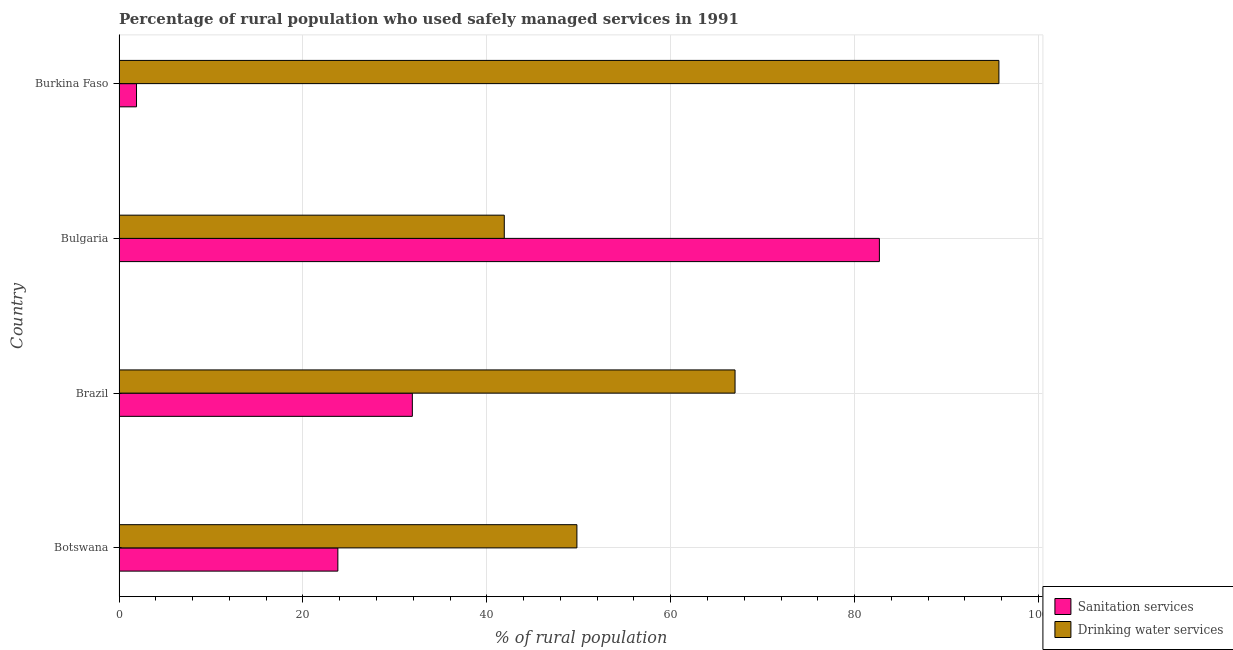How many groups of bars are there?
Provide a succinct answer. 4. Are the number of bars per tick equal to the number of legend labels?
Your response must be concise. Yes. In how many cases, is the number of bars for a given country not equal to the number of legend labels?
Give a very brief answer. 0. What is the percentage of rural population who used drinking water services in Botswana?
Keep it short and to the point. 49.8. Across all countries, what is the maximum percentage of rural population who used sanitation services?
Provide a succinct answer. 82.7. Across all countries, what is the minimum percentage of rural population who used drinking water services?
Give a very brief answer. 41.9. In which country was the percentage of rural population who used sanitation services minimum?
Offer a terse response. Burkina Faso. What is the total percentage of rural population who used drinking water services in the graph?
Provide a succinct answer. 254.4. What is the difference between the percentage of rural population who used sanitation services in Botswana and that in Bulgaria?
Your answer should be compact. -58.9. What is the average percentage of rural population who used sanitation services per country?
Ensure brevity in your answer.  35.08. What is the difference between the percentage of rural population who used sanitation services and percentage of rural population who used drinking water services in Bulgaria?
Keep it short and to the point. 40.8. In how many countries, is the percentage of rural population who used sanitation services greater than 24 %?
Give a very brief answer. 2. What is the ratio of the percentage of rural population who used sanitation services in Botswana to that in Bulgaria?
Ensure brevity in your answer.  0.29. Is the difference between the percentage of rural population who used sanitation services in Botswana and Burkina Faso greater than the difference between the percentage of rural population who used drinking water services in Botswana and Burkina Faso?
Provide a succinct answer. Yes. What is the difference between the highest and the second highest percentage of rural population who used sanitation services?
Your response must be concise. 50.8. What is the difference between the highest and the lowest percentage of rural population who used sanitation services?
Your answer should be very brief. 80.8. In how many countries, is the percentage of rural population who used drinking water services greater than the average percentage of rural population who used drinking water services taken over all countries?
Offer a very short reply. 2. What does the 1st bar from the top in Burkina Faso represents?
Keep it short and to the point. Drinking water services. What does the 2nd bar from the bottom in Brazil represents?
Give a very brief answer. Drinking water services. How many bars are there?
Provide a short and direct response. 8. How many countries are there in the graph?
Make the answer very short. 4. What is the difference between two consecutive major ticks on the X-axis?
Offer a very short reply. 20. Does the graph contain any zero values?
Offer a very short reply. No. What is the title of the graph?
Provide a short and direct response. Percentage of rural population who used safely managed services in 1991. What is the label or title of the X-axis?
Your answer should be very brief. % of rural population. What is the label or title of the Y-axis?
Provide a short and direct response. Country. What is the % of rural population of Sanitation services in Botswana?
Give a very brief answer. 23.8. What is the % of rural population of Drinking water services in Botswana?
Ensure brevity in your answer.  49.8. What is the % of rural population of Sanitation services in Brazil?
Make the answer very short. 31.9. What is the % of rural population in Drinking water services in Brazil?
Ensure brevity in your answer.  67. What is the % of rural population in Sanitation services in Bulgaria?
Your response must be concise. 82.7. What is the % of rural population in Drinking water services in Bulgaria?
Give a very brief answer. 41.9. What is the % of rural population of Drinking water services in Burkina Faso?
Offer a very short reply. 95.7. Across all countries, what is the maximum % of rural population of Sanitation services?
Offer a very short reply. 82.7. Across all countries, what is the maximum % of rural population in Drinking water services?
Ensure brevity in your answer.  95.7. Across all countries, what is the minimum % of rural population in Drinking water services?
Offer a very short reply. 41.9. What is the total % of rural population of Sanitation services in the graph?
Ensure brevity in your answer.  140.3. What is the total % of rural population in Drinking water services in the graph?
Your answer should be compact. 254.4. What is the difference between the % of rural population of Drinking water services in Botswana and that in Brazil?
Provide a succinct answer. -17.2. What is the difference between the % of rural population of Sanitation services in Botswana and that in Bulgaria?
Your answer should be very brief. -58.9. What is the difference between the % of rural population in Drinking water services in Botswana and that in Bulgaria?
Provide a short and direct response. 7.9. What is the difference between the % of rural population in Sanitation services in Botswana and that in Burkina Faso?
Give a very brief answer. 21.9. What is the difference between the % of rural population of Drinking water services in Botswana and that in Burkina Faso?
Offer a terse response. -45.9. What is the difference between the % of rural population of Sanitation services in Brazil and that in Bulgaria?
Offer a terse response. -50.8. What is the difference between the % of rural population of Drinking water services in Brazil and that in Bulgaria?
Offer a terse response. 25.1. What is the difference between the % of rural population in Drinking water services in Brazil and that in Burkina Faso?
Your response must be concise. -28.7. What is the difference between the % of rural population of Sanitation services in Bulgaria and that in Burkina Faso?
Provide a succinct answer. 80.8. What is the difference between the % of rural population of Drinking water services in Bulgaria and that in Burkina Faso?
Ensure brevity in your answer.  -53.8. What is the difference between the % of rural population of Sanitation services in Botswana and the % of rural population of Drinking water services in Brazil?
Keep it short and to the point. -43.2. What is the difference between the % of rural population in Sanitation services in Botswana and the % of rural population in Drinking water services in Bulgaria?
Your response must be concise. -18.1. What is the difference between the % of rural population in Sanitation services in Botswana and the % of rural population in Drinking water services in Burkina Faso?
Provide a short and direct response. -71.9. What is the difference between the % of rural population of Sanitation services in Brazil and the % of rural population of Drinking water services in Bulgaria?
Your answer should be compact. -10. What is the difference between the % of rural population of Sanitation services in Brazil and the % of rural population of Drinking water services in Burkina Faso?
Your answer should be very brief. -63.8. What is the difference between the % of rural population of Sanitation services in Bulgaria and the % of rural population of Drinking water services in Burkina Faso?
Your response must be concise. -13. What is the average % of rural population of Sanitation services per country?
Offer a very short reply. 35.08. What is the average % of rural population in Drinking water services per country?
Make the answer very short. 63.6. What is the difference between the % of rural population in Sanitation services and % of rural population in Drinking water services in Brazil?
Give a very brief answer. -35.1. What is the difference between the % of rural population of Sanitation services and % of rural population of Drinking water services in Bulgaria?
Keep it short and to the point. 40.8. What is the difference between the % of rural population in Sanitation services and % of rural population in Drinking water services in Burkina Faso?
Your response must be concise. -93.8. What is the ratio of the % of rural population in Sanitation services in Botswana to that in Brazil?
Provide a short and direct response. 0.75. What is the ratio of the % of rural population of Drinking water services in Botswana to that in Brazil?
Give a very brief answer. 0.74. What is the ratio of the % of rural population in Sanitation services in Botswana to that in Bulgaria?
Ensure brevity in your answer.  0.29. What is the ratio of the % of rural population in Drinking water services in Botswana to that in Bulgaria?
Make the answer very short. 1.19. What is the ratio of the % of rural population in Sanitation services in Botswana to that in Burkina Faso?
Make the answer very short. 12.53. What is the ratio of the % of rural population in Drinking water services in Botswana to that in Burkina Faso?
Provide a succinct answer. 0.52. What is the ratio of the % of rural population of Sanitation services in Brazil to that in Bulgaria?
Give a very brief answer. 0.39. What is the ratio of the % of rural population of Drinking water services in Brazil to that in Bulgaria?
Your answer should be very brief. 1.6. What is the ratio of the % of rural population of Sanitation services in Brazil to that in Burkina Faso?
Your response must be concise. 16.79. What is the ratio of the % of rural population in Drinking water services in Brazil to that in Burkina Faso?
Offer a very short reply. 0.7. What is the ratio of the % of rural population in Sanitation services in Bulgaria to that in Burkina Faso?
Provide a short and direct response. 43.53. What is the ratio of the % of rural population of Drinking water services in Bulgaria to that in Burkina Faso?
Provide a succinct answer. 0.44. What is the difference between the highest and the second highest % of rural population of Sanitation services?
Provide a succinct answer. 50.8. What is the difference between the highest and the second highest % of rural population in Drinking water services?
Provide a short and direct response. 28.7. What is the difference between the highest and the lowest % of rural population of Sanitation services?
Your response must be concise. 80.8. What is the difference between the highest and the lowest % of rural population in Drinking water services?
Offer a terse response. 53.8. 